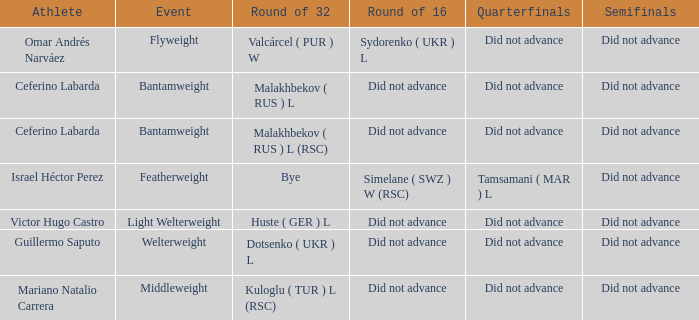In the flyweight division, which athlete took part? Omar Andrés Narváez. Would you be able to parse every entry in this table? {'header': ['Athlete', 'Event', 'Round of 32', 'Round of 16', 'Quarterfinals', 'Semifinals'], 'rows': [['Omar Andrés Narváez', 'Flyweight', 'Valcárcel ( PUR ) W', 'Sydorenko ( UKR ) L', 'Did not advance', 'Did not advance'], ['Ceferino Labarda', 'Bantamweight', 'Malakhbekov ( RUS ) L', 'Did not advance', 'Did not advance', 'Did not advance'], ['Ceferino Labarda', 'Bantamweight', 'Malakhbekov ( RUS ) L (RSC)', 'Did not advance', 'Did not advance', 'Did not advance'], ['Israel Héctor Perez', 'Featherweight', 'Bye', 'Simelane ( SWZ ) W (RSC)', 'Tamsamani ( MAR ) L', 'Did not advance'], ['Victor Hugo Castro', 'Light Welterweight', 'Huste ( GER ) L', 'Did not advance', 'Did not advance', 'Did not advance'], ['Guillermo Saputo', 'Welterweight', 'Dotsenko ( UKR ) L', 'Did not advance', 'Did not advance', 'Did not advance'], ['Mariano Natalio Carrera', 'Middleweight', 'Kuloglu ( TUR ) L (RSC)', 'Did not advance', 'Did not advance', 'Did not advance']]} 